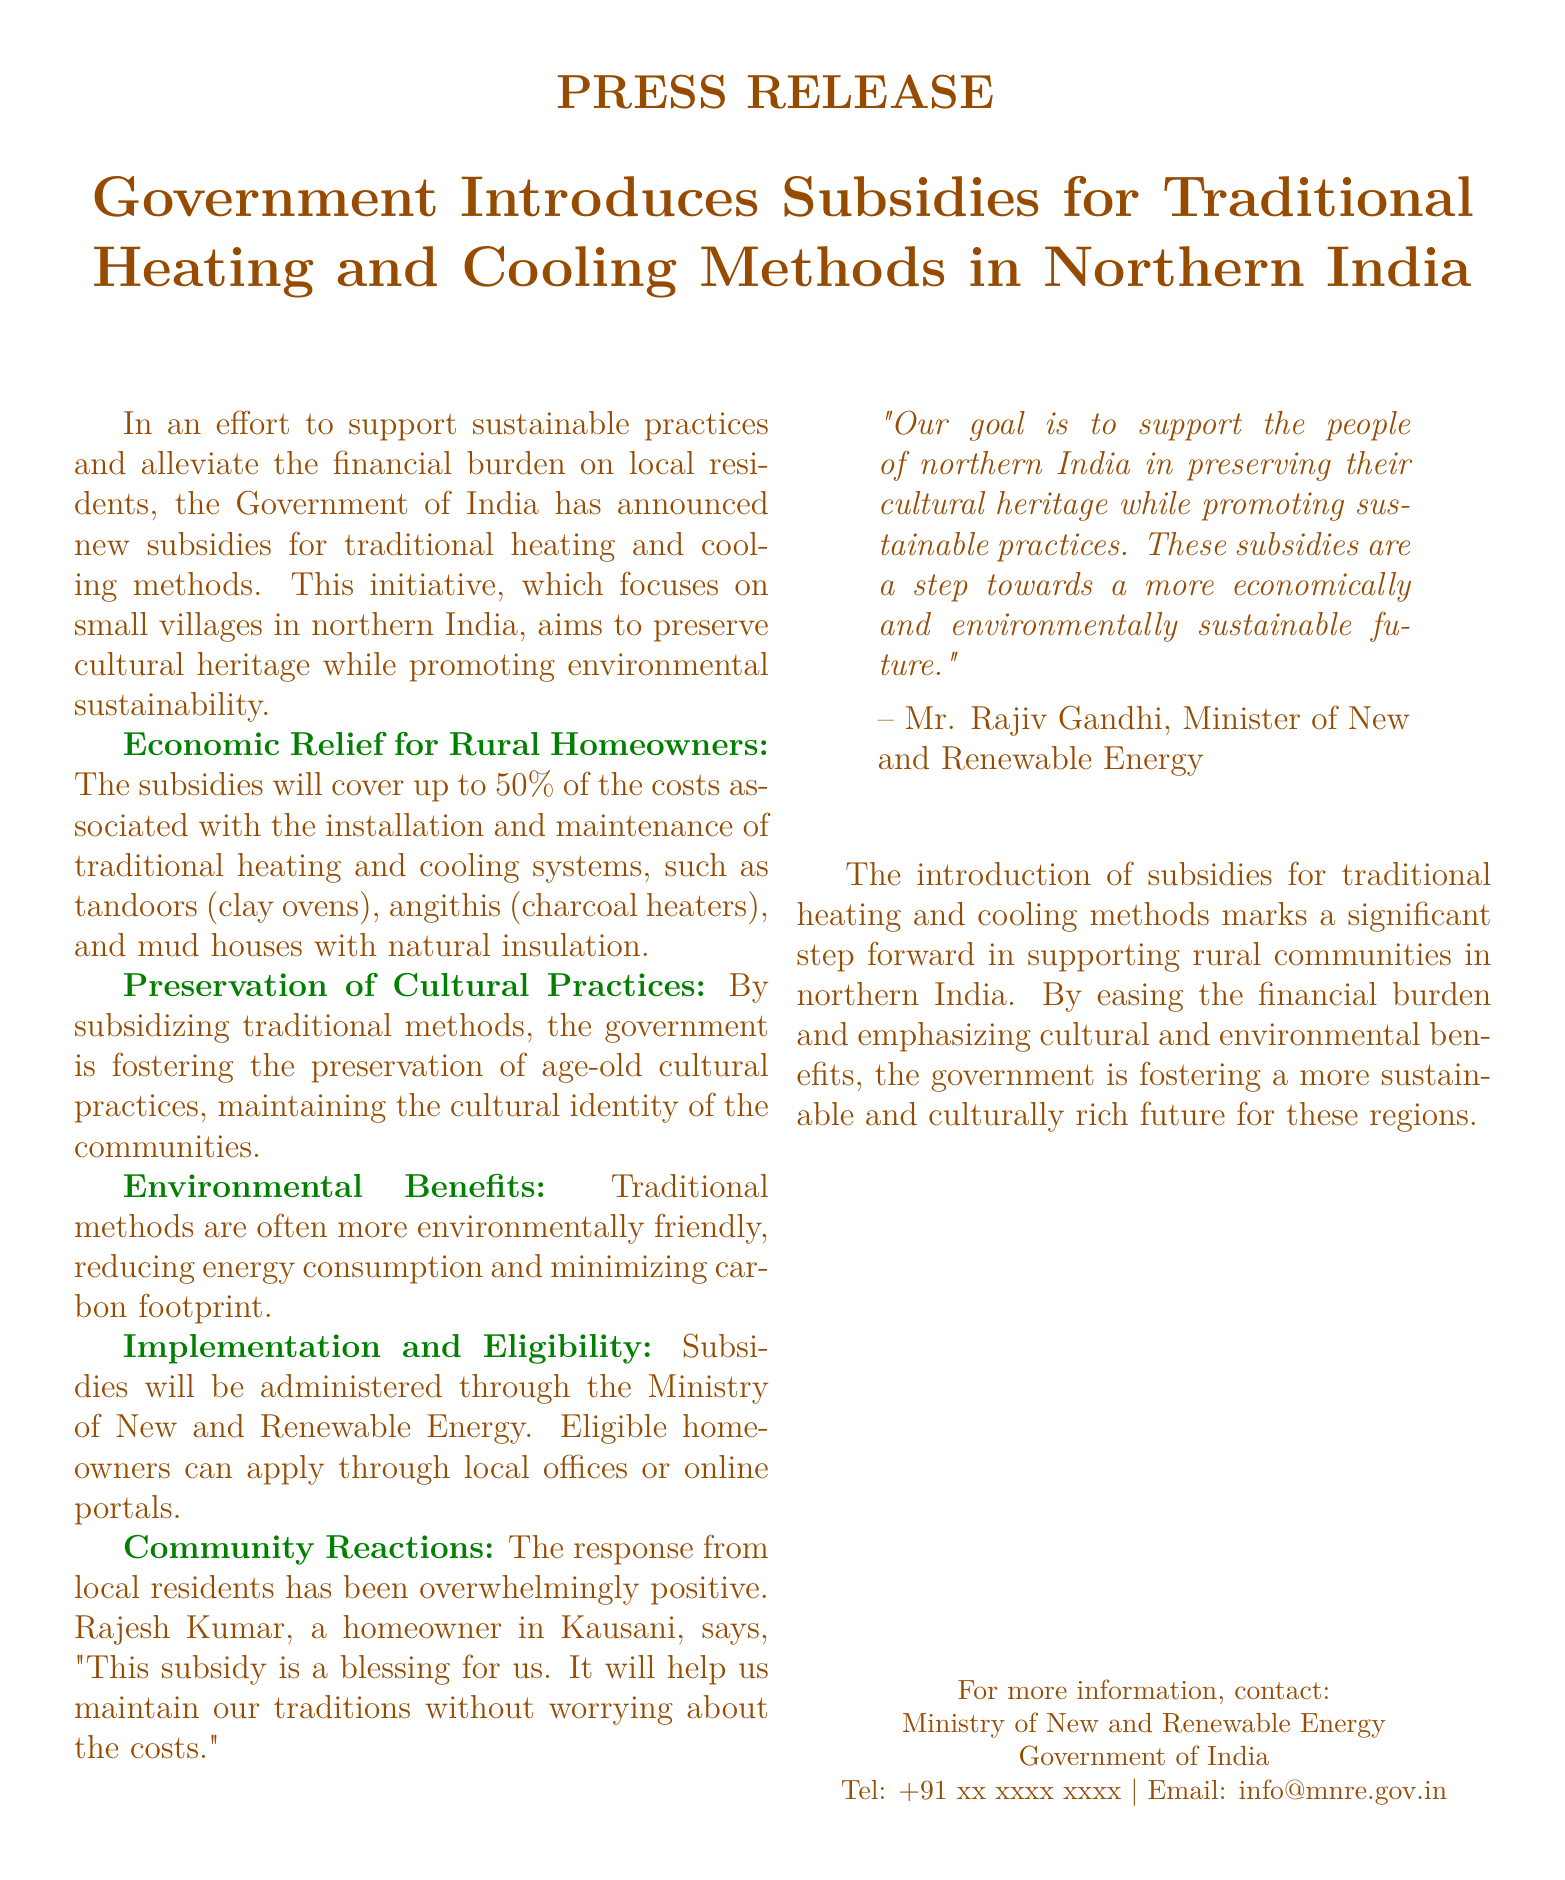What is the maximum coverage of the subsidies? The document states that the subsidies will cover up to 50% of the costs associated with the installation and maintenance of traditional heating and cooling systems.
Answer: 50% Who administers the subsidies? The subsidies will be administered through the Ministry of New and Renewable Energy.
Answer: Ministry of New and Renewable Energy What types of traditional systems are mentioned? The document lists tandoors, angithis, and mud houses with natural insulation as traditional heating and cooling systems.
Answer: tandoors, angithis, mud houses How have local residents reacted to the subsidies? The document mentions that the response from local residents has been overwhelmingly positive.
Answer: overwhelmingly positive Who is quoted in the document regarding the goal of the initiative? The quote regarding the goal of the initiative is attributed to Mr. Rajiv Gandhi, Minister of New and Renewable Energy.
Answer: Mr. Rajiv Gandhi What is the main purpose of the subsidies? The main purpose is to alleviate the financial burden on local residents and support sustainable practices.
Answer: alleviate financial burden Where can eligible homeowners apply for subsidies? Eligible homeowners can apply through local offices or online portals.
Answer: local offices or online portals What impact do the subsidies aim to have on cultural practices? The subsidies aim to foster the preservation of age-old cultural practices and maintain the cultural identity of the communities.
Answer: preserve cultural practices What is the overall theme of the press release? The overall theme is supporting sustainable practices while preserving cultural heritage in northern India.
Answer: supporting sustainable practices 